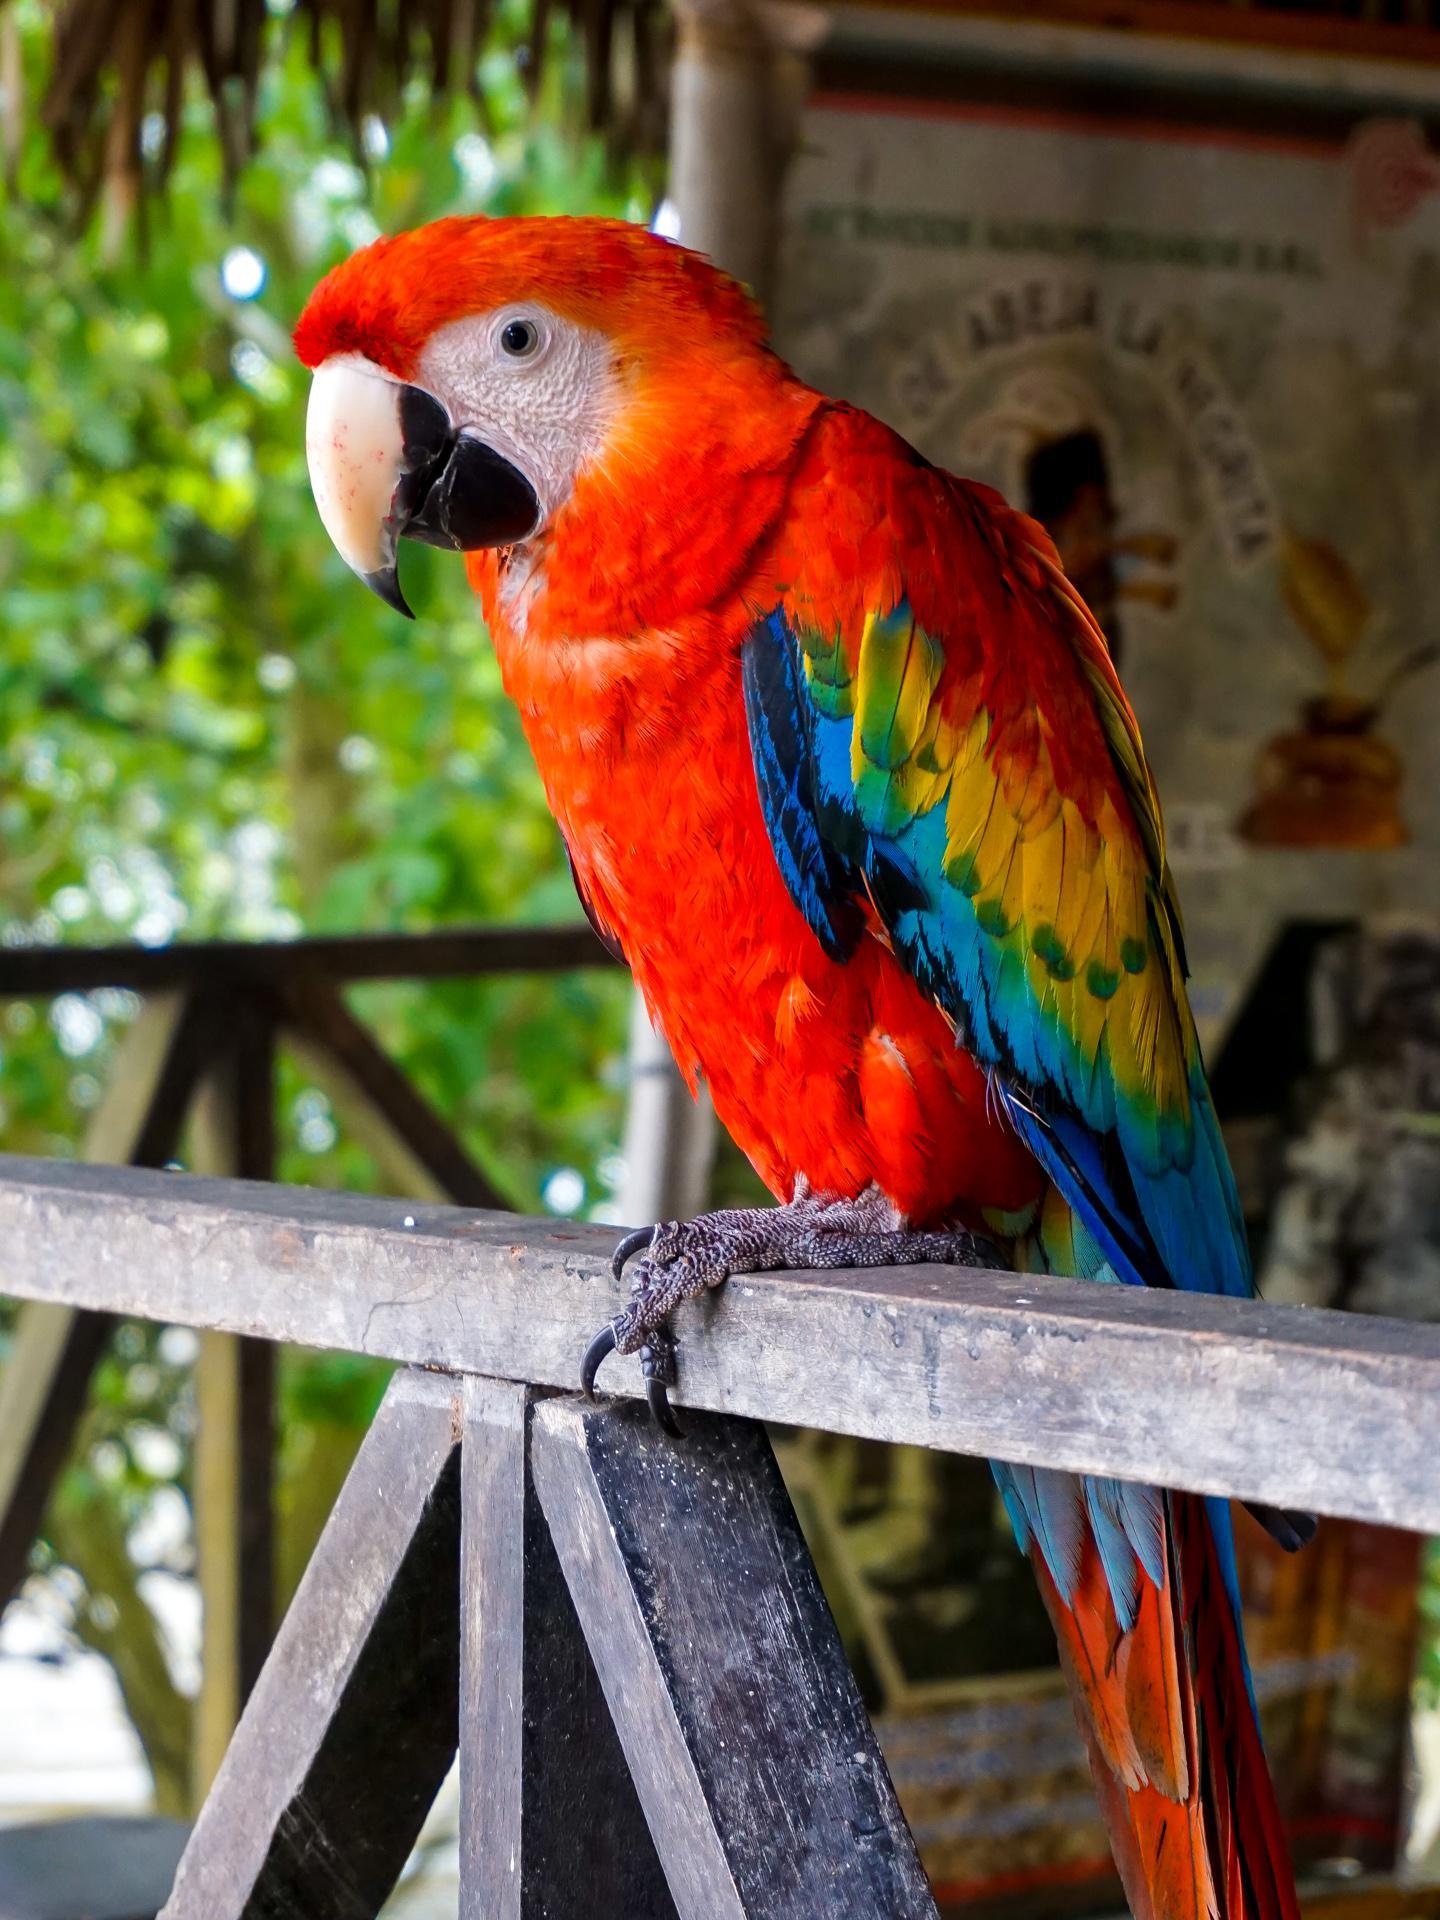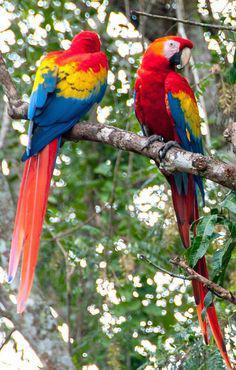The first image is the image on the left, the second image is the image on the right. For the images shown, is this caption "There are less than four birds." true? Answer yes or no. Yes. The first image is the image on the left, the second image is the image on the right. Considering the images on both sides, is "More than four parrots are standing on the same stick and facing the same direction." valid? Answer yes or no. No. 